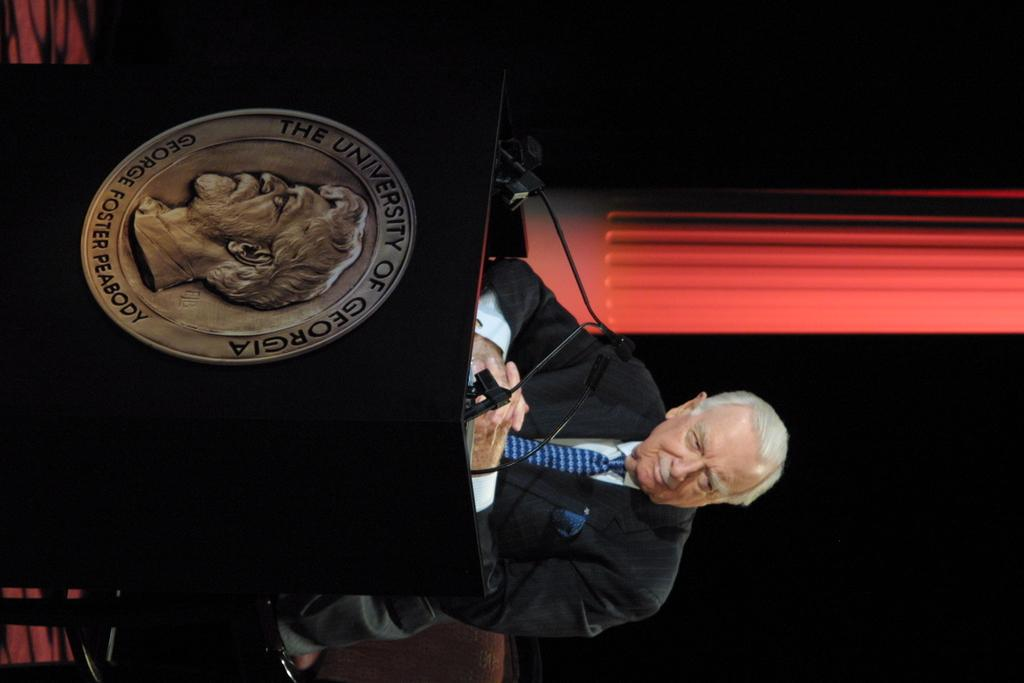<image>
Share a concise interpretation of the image provided. The podium coin reads The University Of Georgia 